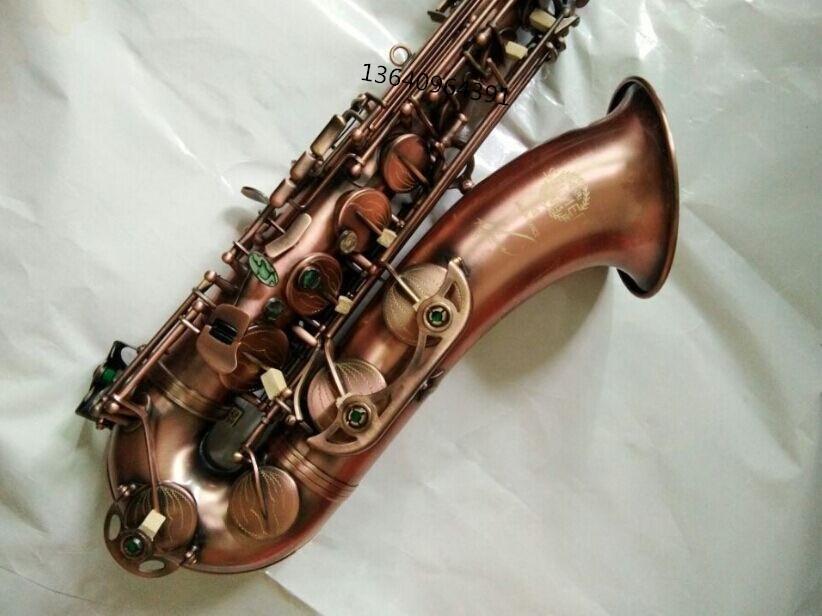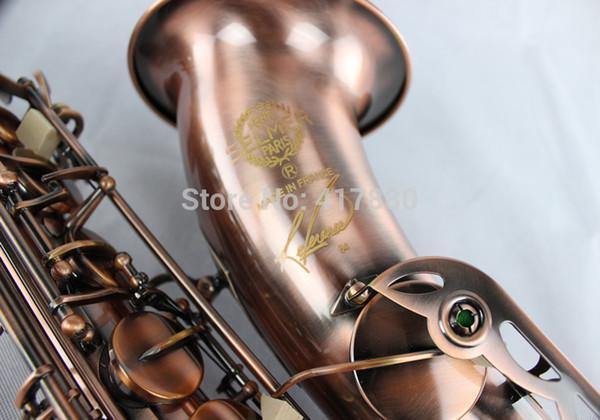The first image is the image on the left, the second image is the image on the right. Assess this claim about the two images: "An image includes more than one saxophone.". Correct or not? Answer yes or no. No. The first image is the image on the left, the second image is the image on the right. Assess this claim about the two images: "Two saxophones with no musicians are lying down.". Correct or not? Answer yes or no. Yes. 